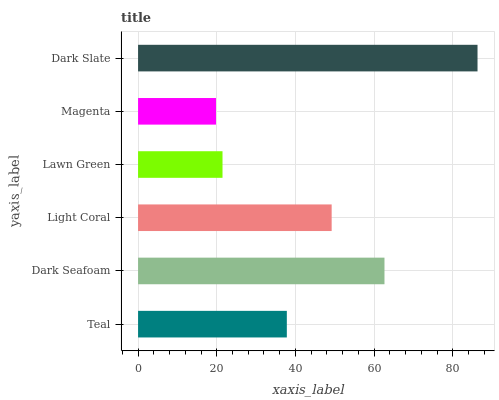Is Magenta the minimum?
Answer yes or no. Yes. Is Dark Slate the maximum?
Answer yes or no. Yes. Is Dark Seafoam the minimum?
Answer yes or no. No. Is Dark Seafoam the maximum?
Answer yes or no. No. Is Dark Seafoam greater than Teal?
Answer yes or no. Yes. Is Teal less than Dark Seafoam?
Answer yes or no. Yes. Is Teal greater than Dark Seafoam?
Answer yes or no. No. Is Dark Seafoam less than Teal?
Answer yes or no. No. Is Light Coral the high median?
Answer yes or no. Yes. Is Teal the low median?
Answer yes or no. Yes. Is Teal the high median?
Answer yes or no. No. Is Dark Seafoam the low median?
Answer yes or no. No. 